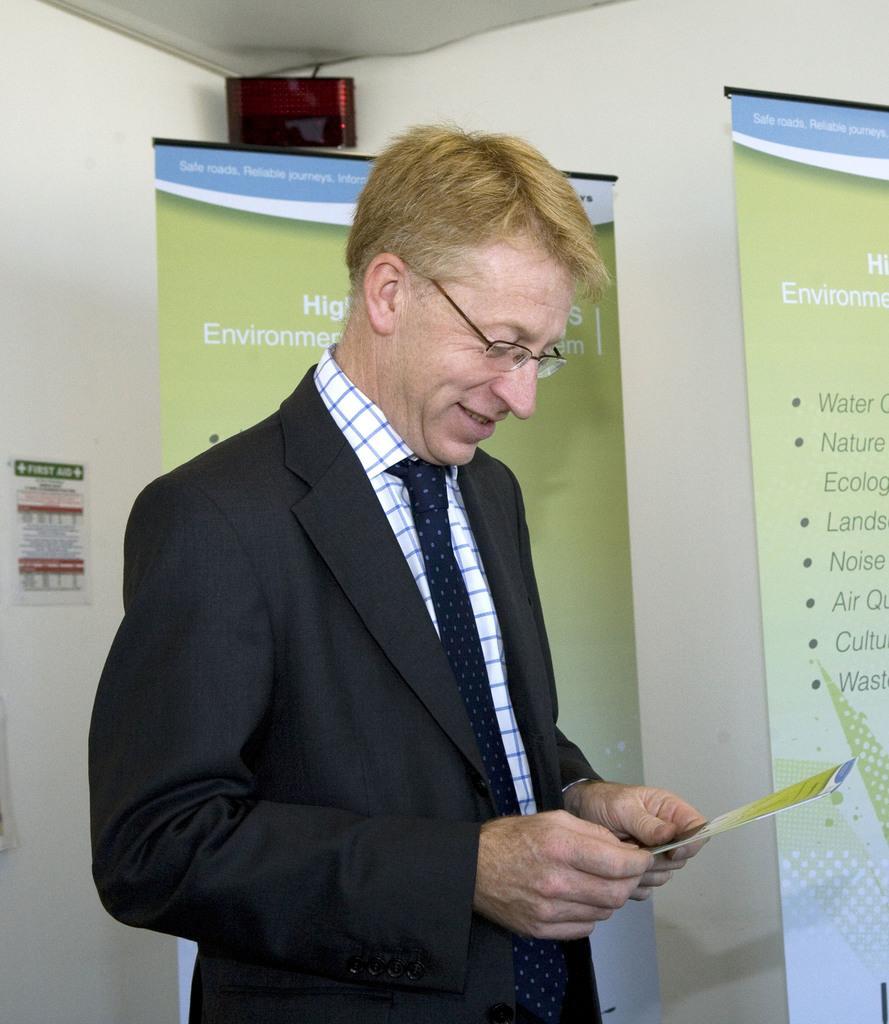Please provide a concise description of this image. In this image we can see this person wearing blazer, shirt, tie and spectacles is standing here and smiling. In the background, we can see the banners, LED display and the wall. 